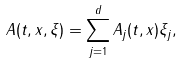Convert formula to latex. <formula><loc_0><loc_0><loc_500><loc_500>A ( t , x , \xi ) = \sum _ { j = 1 } ^ { d } A _ { j } ( t , x ) \xi _ { j } ,</formula> 